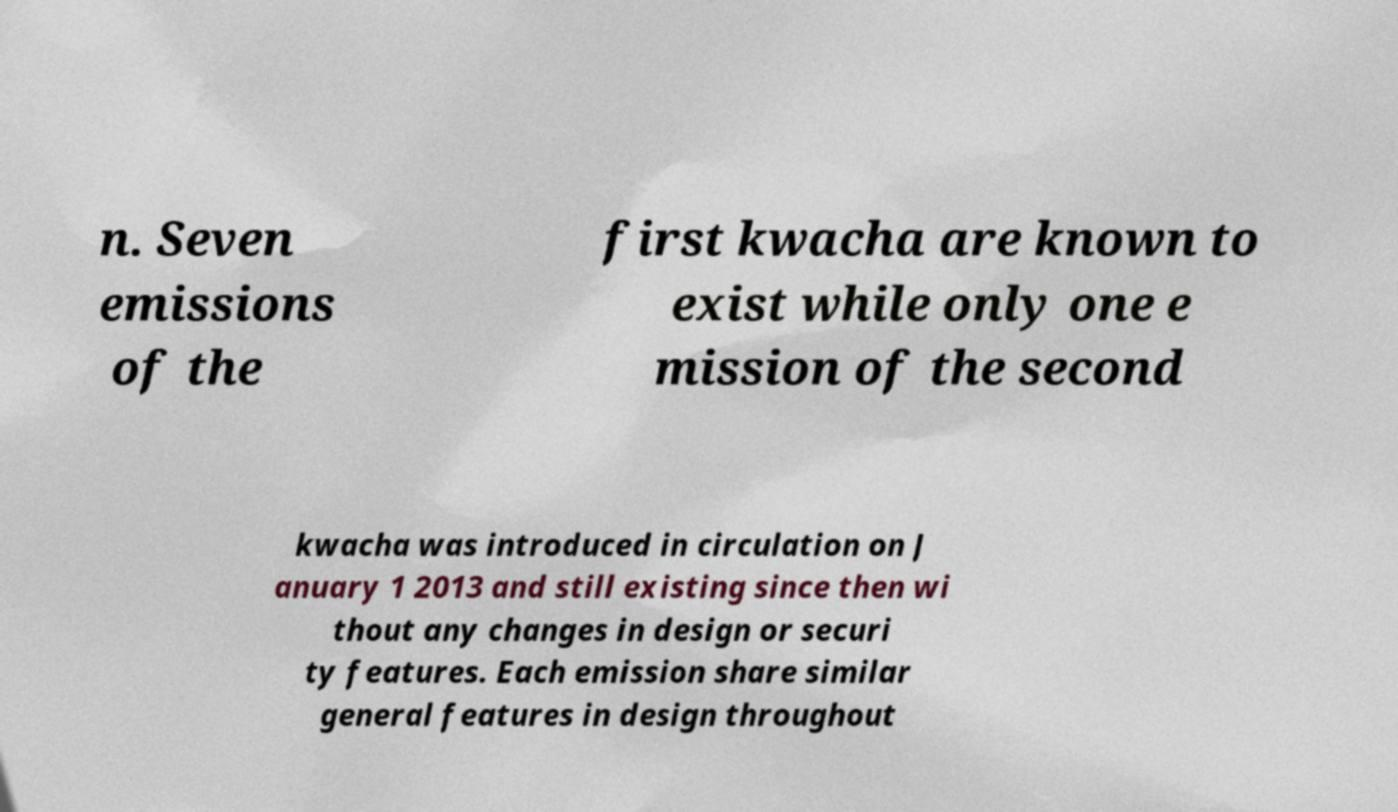Could you assist in decoding the text presented in this image and type it out clearly? n. Seven emissions of the first kwacha are known to exist while only one e mission of the second kwacha was introduced in circulation on J anuary 1 2013 and still existing since then wi thout any changes in design or securi ty features. Each emission share similar general features in design throughout 